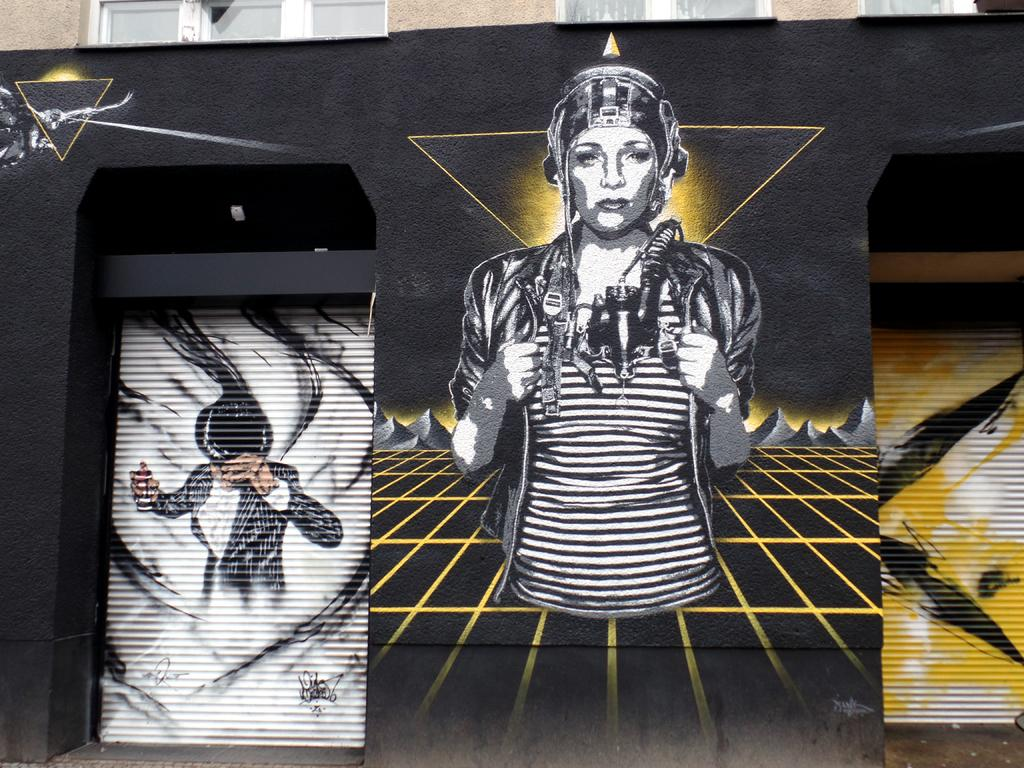What is on the wall in the image? There is a depiction on the wall in the image. What type of connection is being made in the throat of the person in the image? There is no person or throat present in the image; it only features a depiction on the wall. 